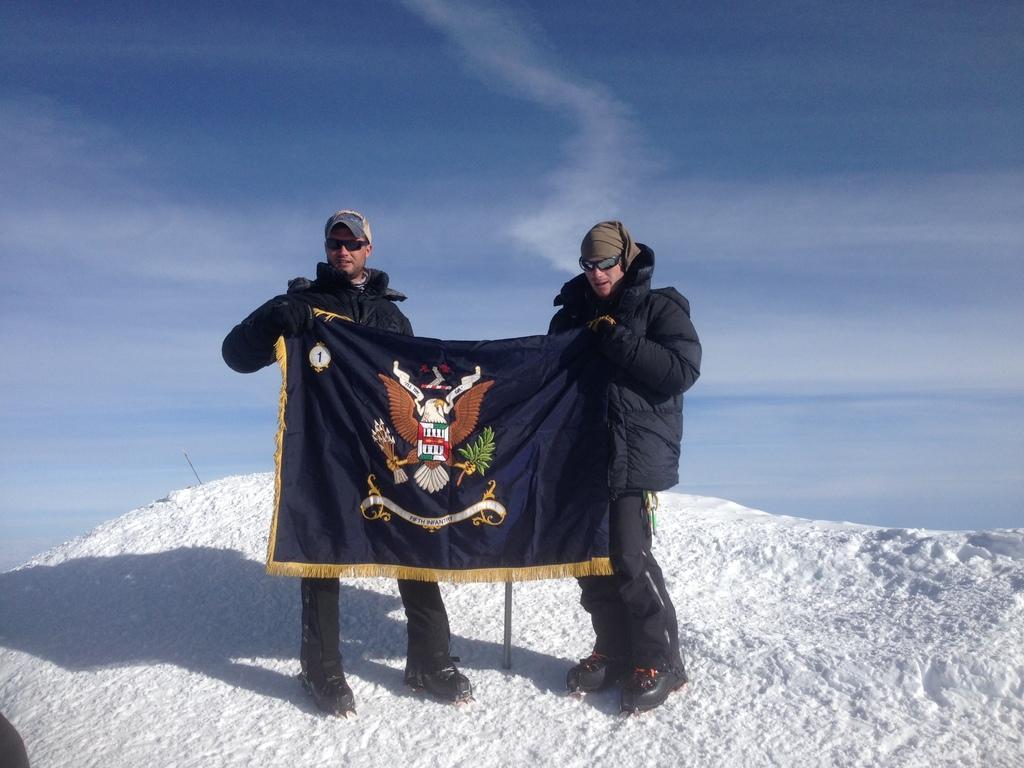Can you describe this image briefly? In this image, we can see people wearing coats, caps and glasses and are holding a banner. In the background, there is sky and at the bottom, there is snow. 